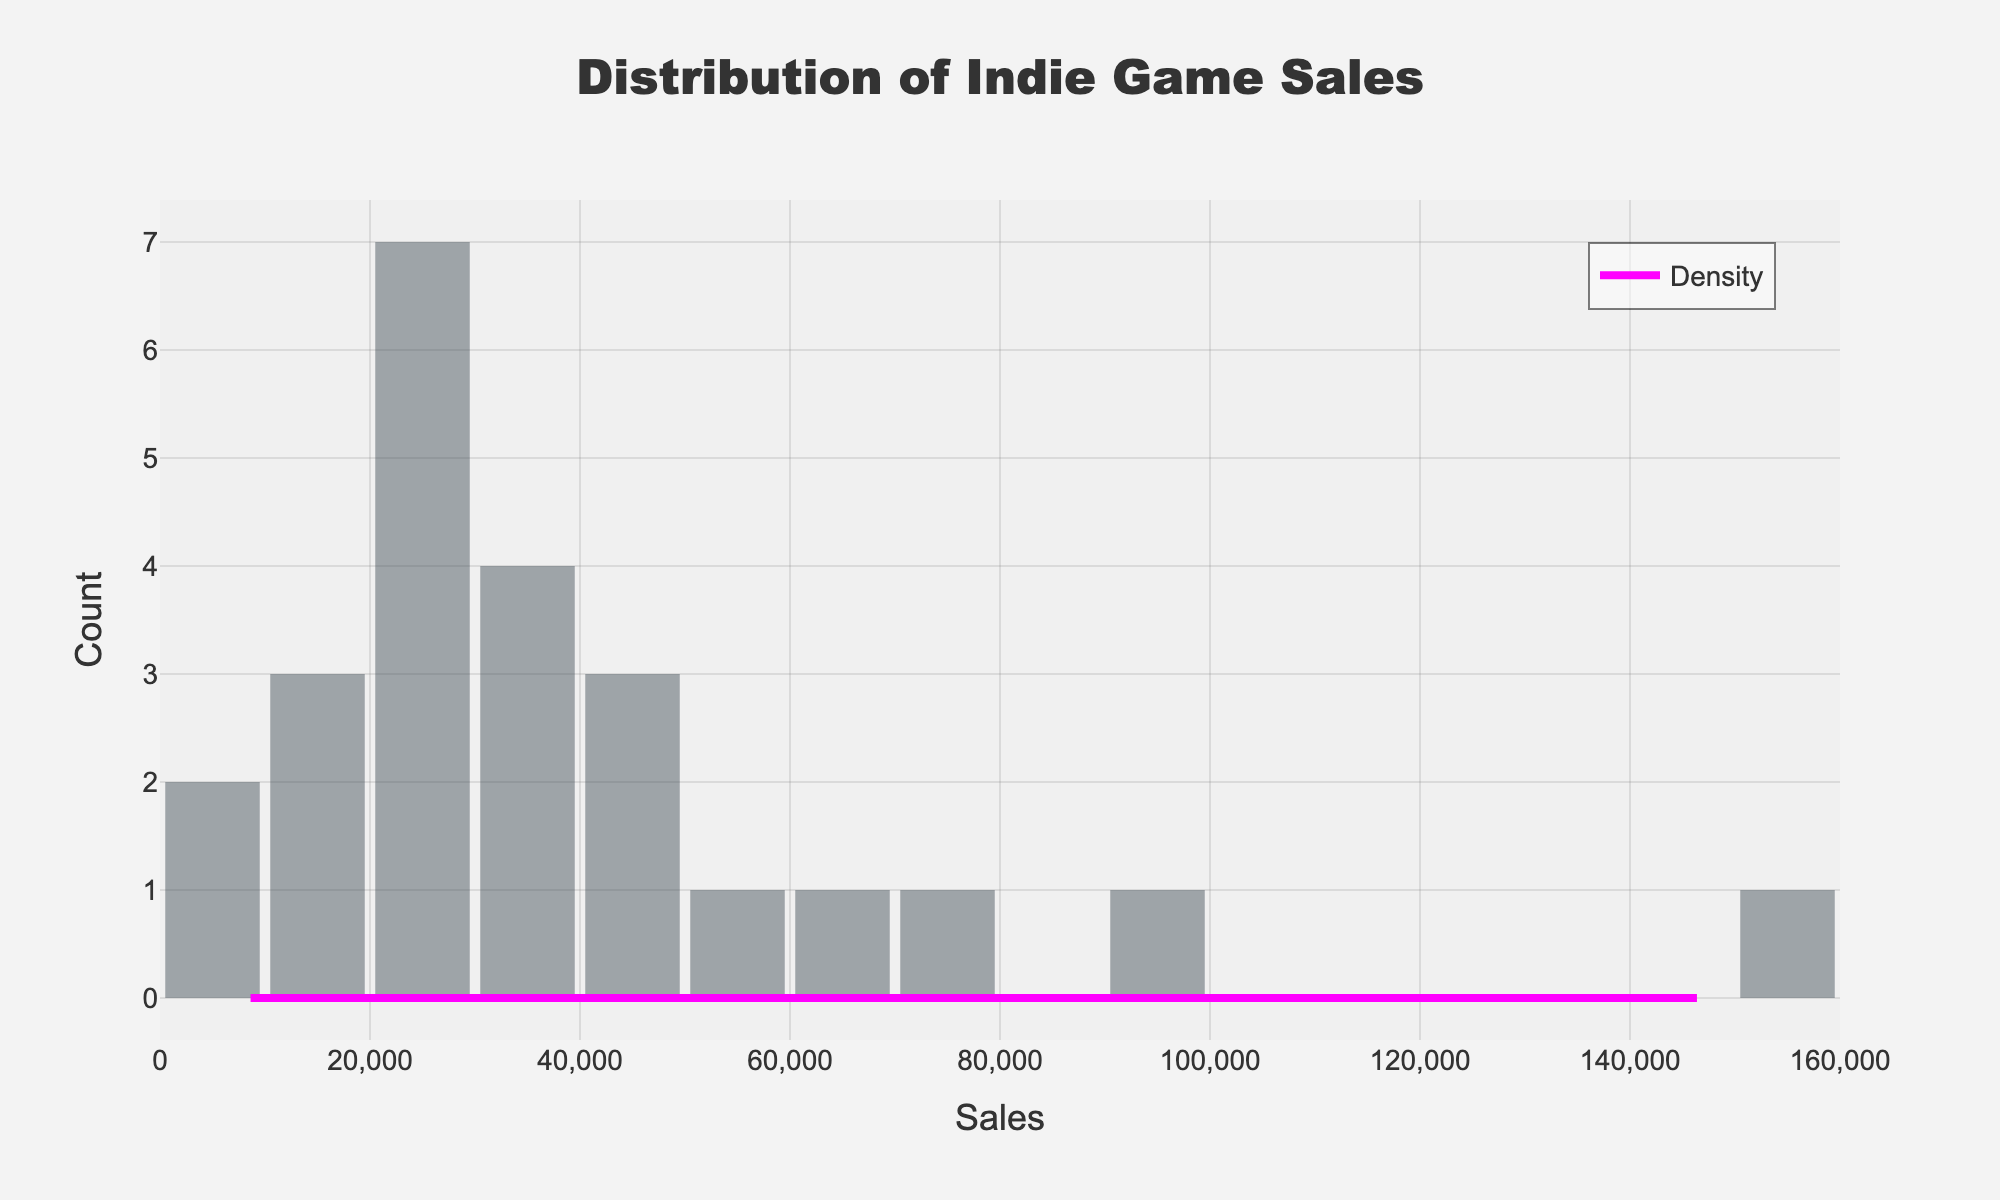how many data points fall under the highest bin in the histogram? identify the highest bar on the histogram by its height. count the number of data points represented by the height of that bar.
Answer: (number of data points) Which platform shows the highest indie game sales according to the histogram? look for the tallest bar in the histogram corresponding to a particular sales range, and identify the platform associated with this bar from the overall sales data.
Answer: (platform) What is the approximate range with the highest density of game sales? examine the kde curve to find the peak point that represents the highest density. the sales range under this peak is the range with the highest density.
Answer: (sales range) How do action genre sales compare to puzzle genre sales according to the kde? identify the peak densities of the kde curve at sales values representing the action and puzzle genres from the data provided. compare the kde heights of both genres.
Answer: (comparison) What sales range covers the majority of indie game sales? find the range with most data points by identifying the bars covering the middle area of the histogram. these should overlap with the highest peak of the kde curve.
Answer: (sales range) 